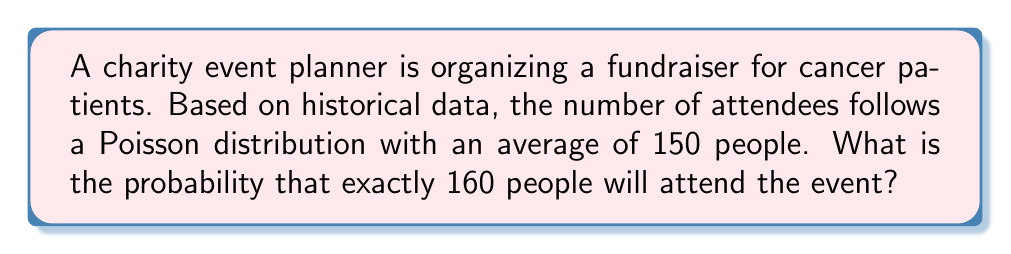Could you help me with this problem? To solve this problem, we'll use the Poisson distribution formula:

$$P(X = k) = \frac{e^{-\lambda} \lambda^k}{k!}$$

Where:
$\lambda$ = average number of attendees (150)
$k$ = specific number of attendees we're calculating for (160)
$e$ = Euler's number (approximately 2.71828)

Step 1: Plug in the values into the formula
$$P(X = 160) = \frac{e^{-150} 150^{160}}{160!}$$

Step 2: Calculate $e^{-150}$
$$e^{-150} \approx 7.1795 \times 10^{-66}$$

Step 3: Calculate $150^{160}$
$$150^{160} \approx 1.4378 \times 10^{368}$$

Step 4: Calculate 160!
$$160! \approx 4.7147 \times 10^{284}$$

Step 5: Combine all parts and calculate the final probability
$$P(X = 160) = \frac{(7.1795 \times 10^{-66}) \times (1.4378 \times 10^{368})}{4.7147 \times 10^{284}} \approx 0.0218$$

Step 6: Convert to percentage
$$0.0218 \times 100\% = 2.18\%$$
Answer: 2.18% 